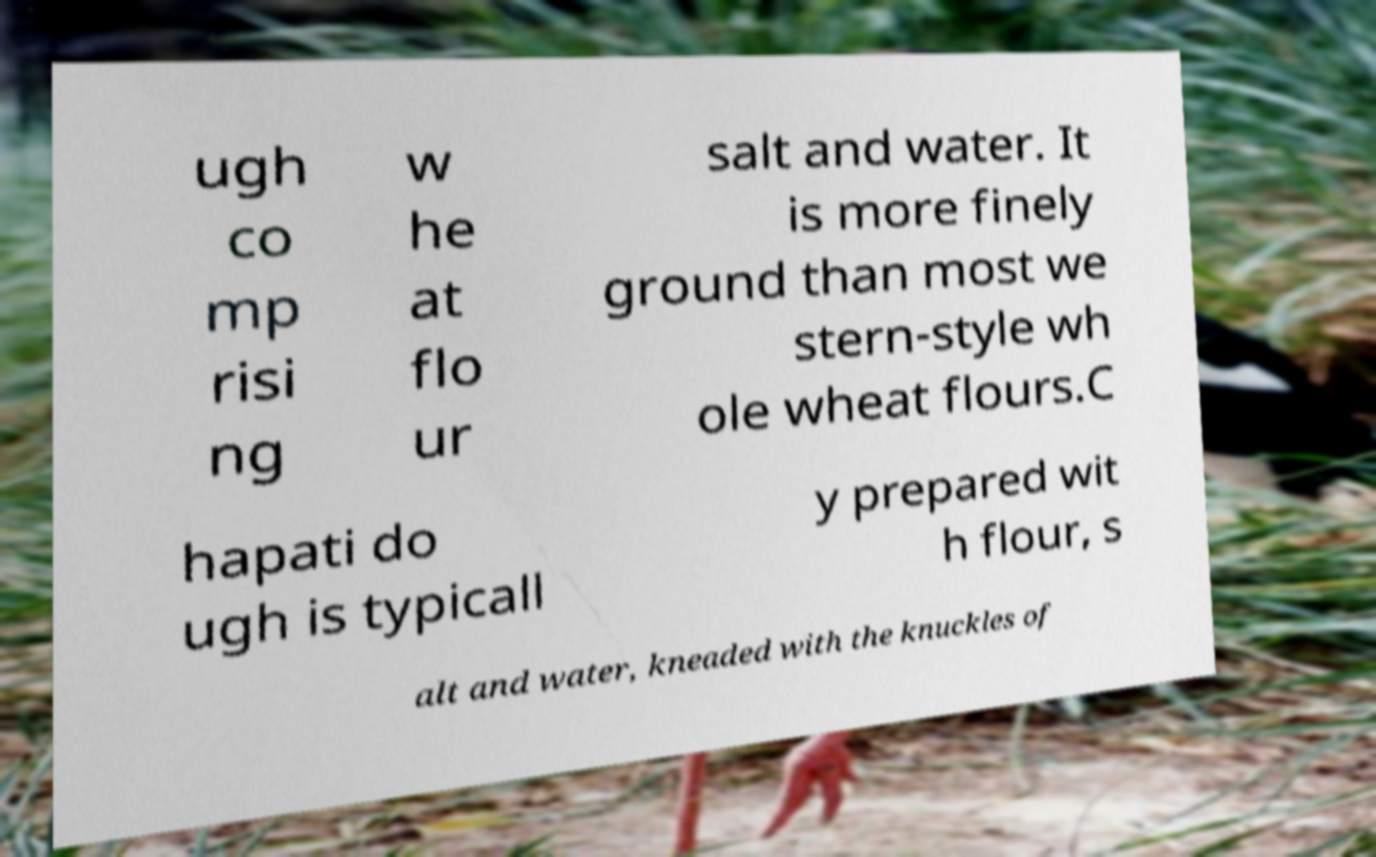For documentation purposes, I need the text within this image transcribed. Could you provide that? ugh co mp risi ng w he at flo ur salt and water. It is more finely ground than most we stern-style wh ole wheat flours.C hapati do ugh is typicall y prepared wit h flour, s alt and water, kneaded with the knuckles of 